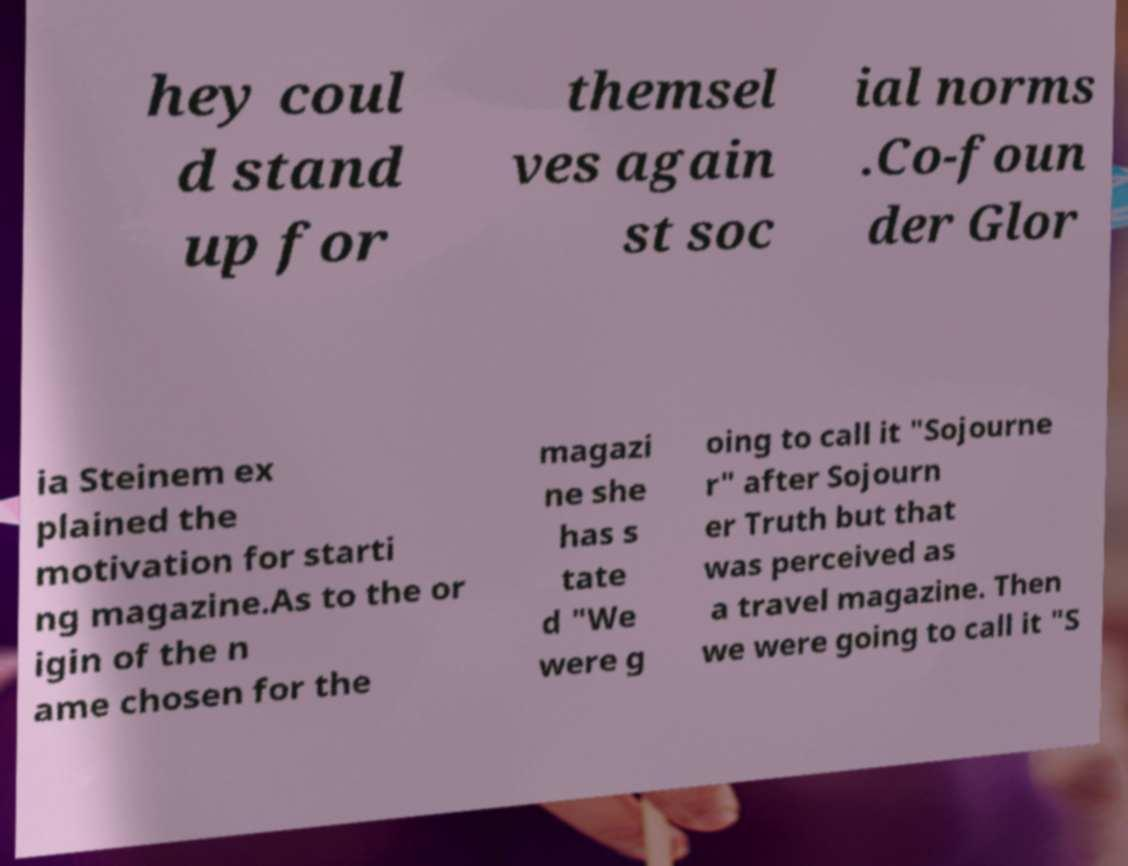I need the written content from this picture converted into text. Can you do that? hey coul d stand up for themsel ves again st soc ial norms .Co-foun der Glor ia Steinem ex plained the motivation for starti ng magazine.As to the or igin of the n ame chosen for the magazi ne she has s tate d "We were g oing to call it "Sojourne r" after Sojourn er Truth but that was perceived as a travel magazine. Then we were going to call it "S 